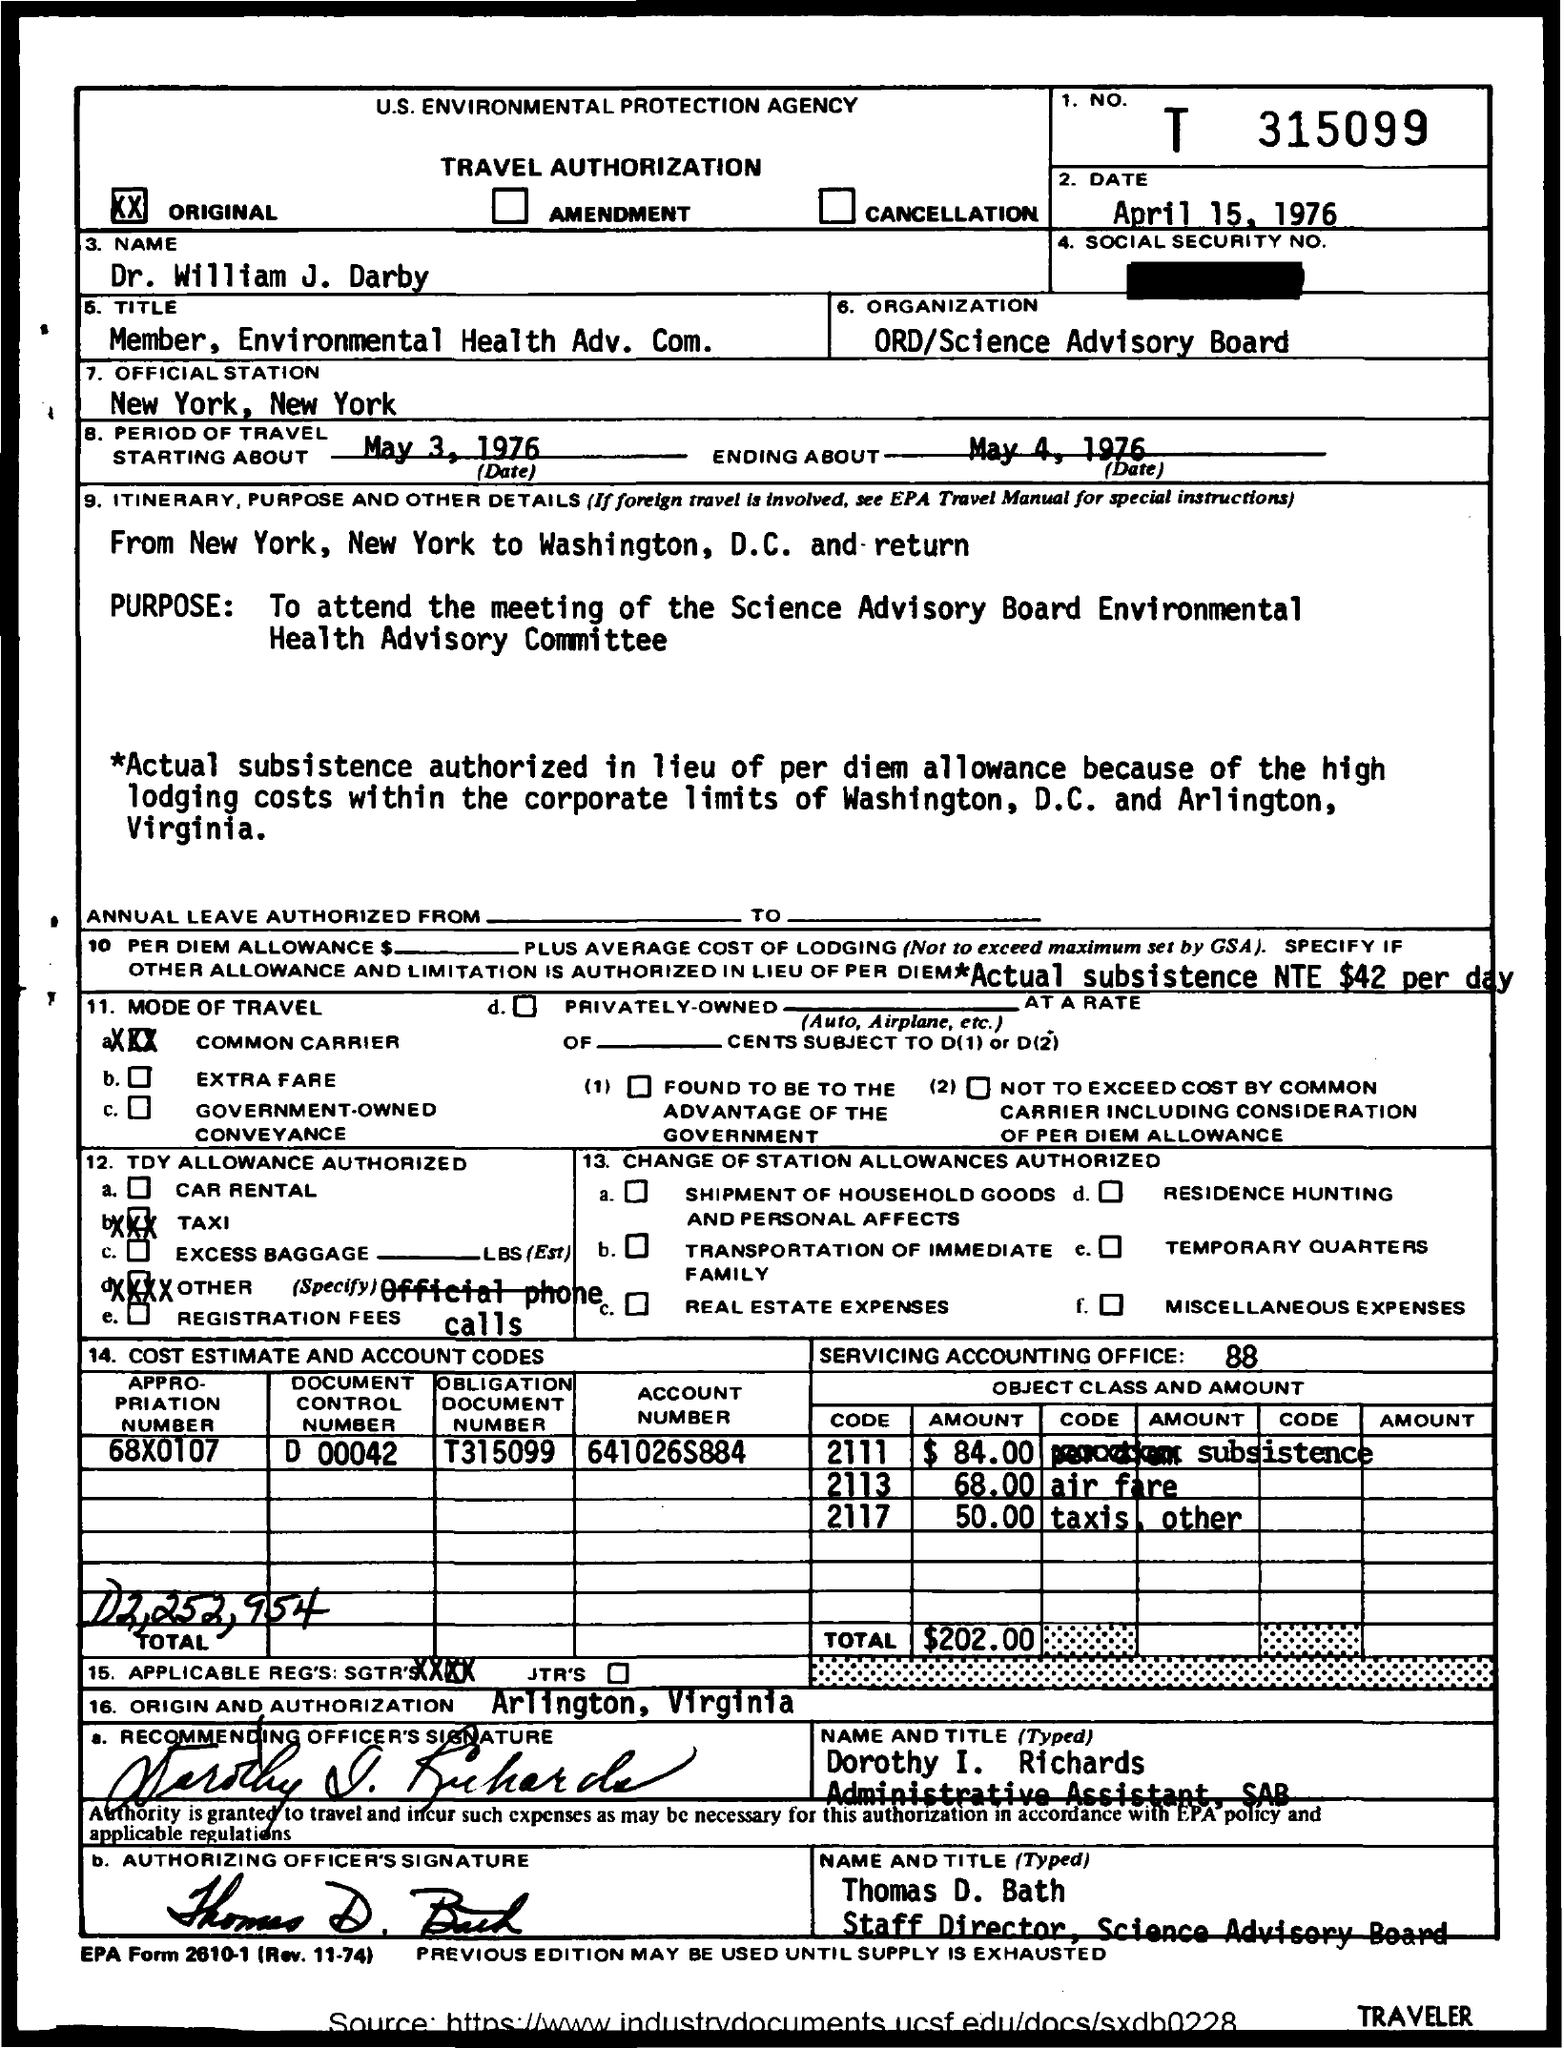Mention a couple of crucial points in this snapshot. The period of travel began on May 3, 1976. The form was submitted on April 15, 1976. The form titled "TRAVEL AUTHORIZATION" is intended for the purpose of authorizing travel-related activities. The purpose of travel is to attend the meeting of the Science Advisory Board Environmental Health Advisory Committee. 